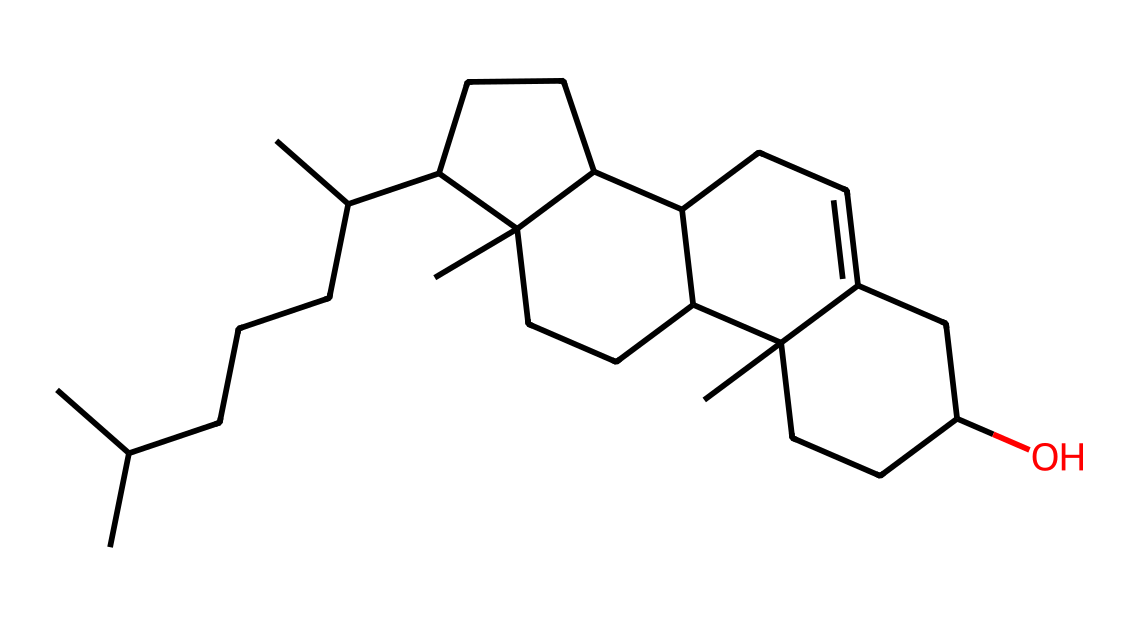What is the molecular formula of the chemical represented by this SMILES? To find the molecular formula from the SMILES, we need to count the number of carbon (C), hydrogen (H), and oxygen (O) atoms in the structure. From the given SMILES, we can deduce that there are 27 carbon atoms (C) and 46 hydrogen atoms (H) with one oxygen (O) atom.
Answer: C27H46O How many rings are present in the cholesterol structure? By examining the structure from the SMILES, we can identify the rings by looking for any cyclic components. Cholesterol has four interconnected rings, which can be observed in its usual structural representation.
Answer: 4 What functional group is present in cholesterol? The presence of -OH (hydroxyl) functional group can be identified from the structure indicated by the ending part of the SMILES. Alcohols, signified by this group, are part of cholesterol's structure.
Answer: hydroxyl Which type of lipid classification does cholesterol belong to? Cholesterol is classified as a sterol due to its specific multi-ring structure and hydroxyl group, which fits the characteristics of sterols within lipid classification.
Answer: sterol How does cholesterol affect membrane fluidity? Cholesterol is known to regulate membrane fluidity by fitting between phospholipids in the bilayer, reducing membrane permeability at high temperatures and preventing solidification at low temperatures.
Answer: maintain fluidity 